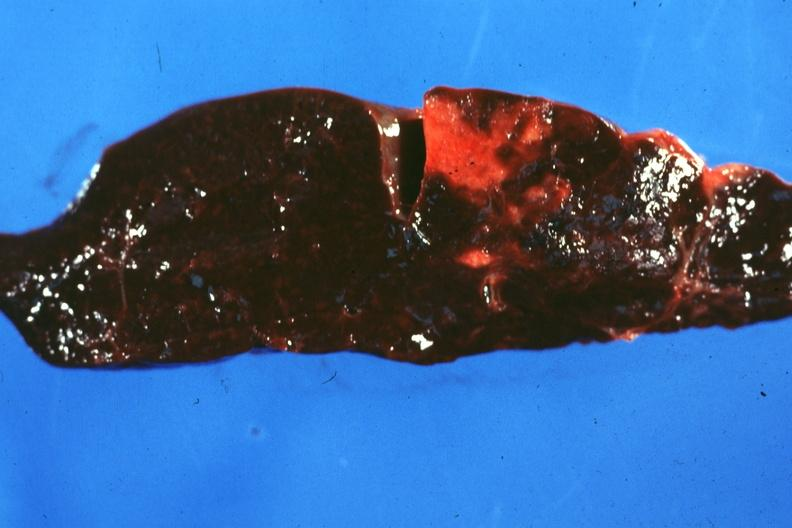s hematologic present?
Answer the question using a single word or phrase. Yes 